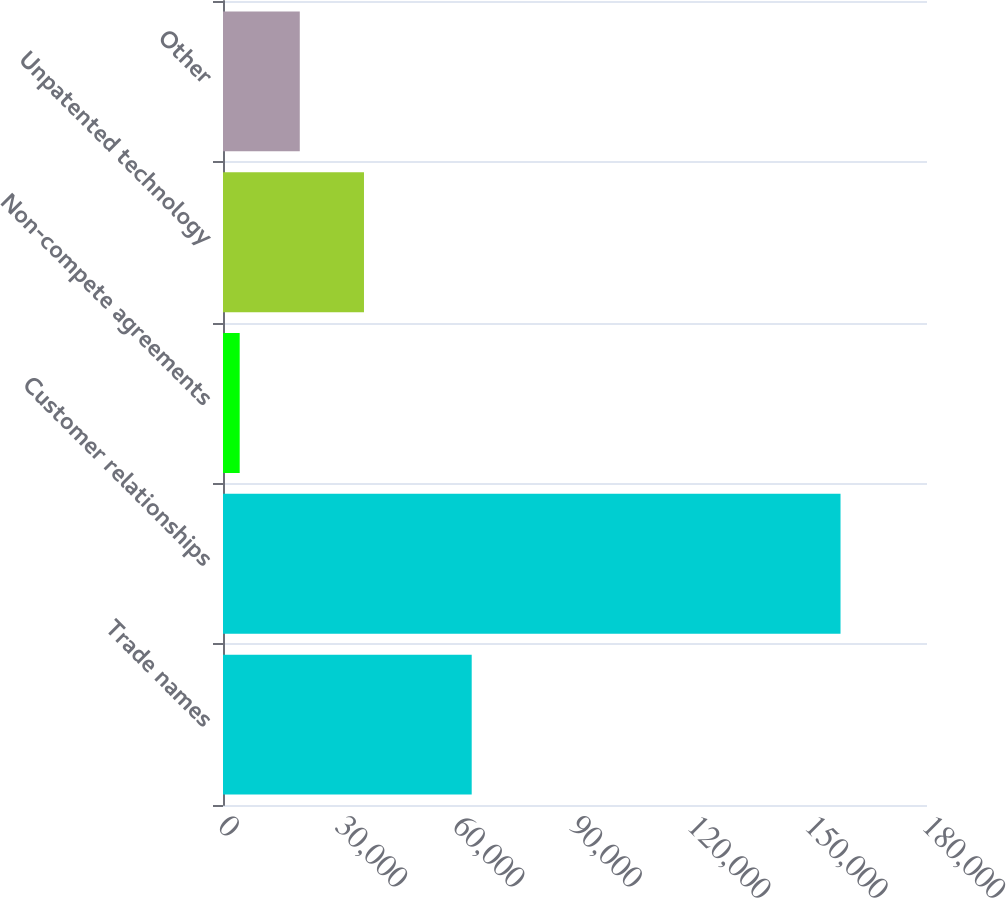Convert chart to OTSL. <chart><loc_0><loc_0><loc_500><loc_500><bar_chart><fcel>Trade names<fcel>Customer relationships<fcel>Non-compete agreements<fcel>Unpatented technology<fcel>Other<nl><fcel>63589<fcel>157890<fcel>4268<fcel>36047<fcel>19630.2<nl></chart> 